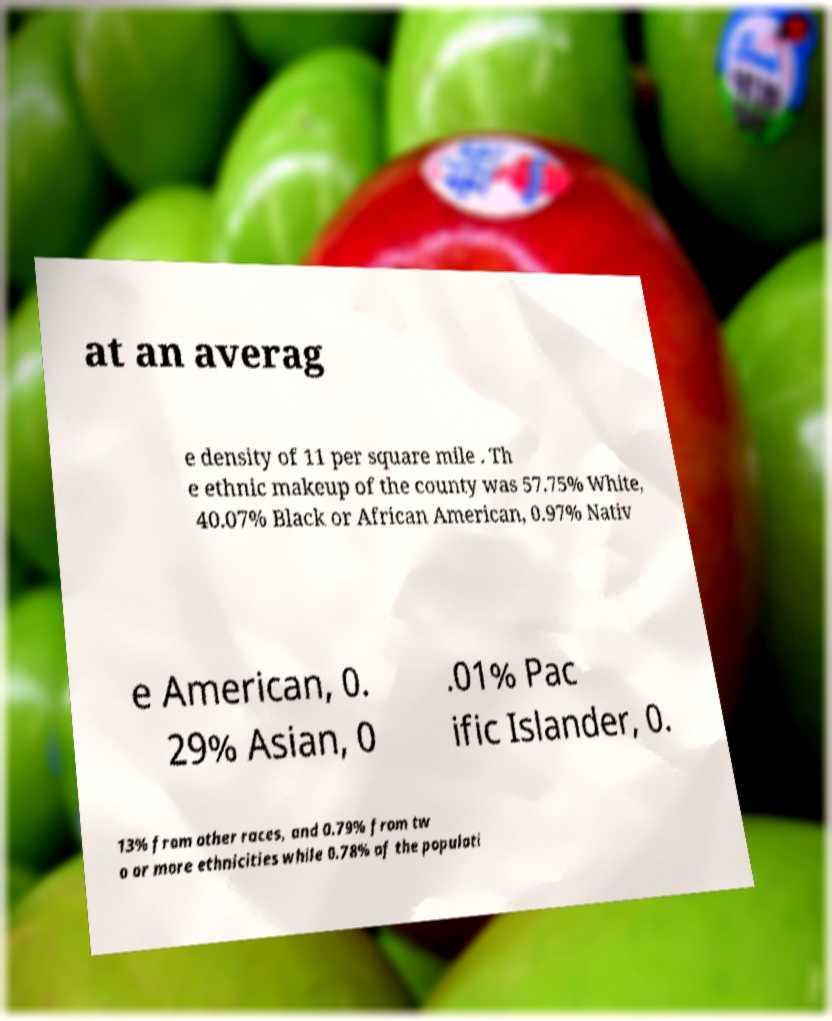Can you read and provide the text displayed in the image?This photo seems to have some interesting text. Can you extract and type it out for me? at an averag e density of 11 per square mile . Th e ethnic makeup of the county was 57.75% White, 40.07% Black or African American, 0.97% Nativ e American, 0. 29% Asian, 0 .01% Pac ific Islander, 0. 13% from other races, and 0.79% from tw o or more ethnicities while 0.78% of the populati 